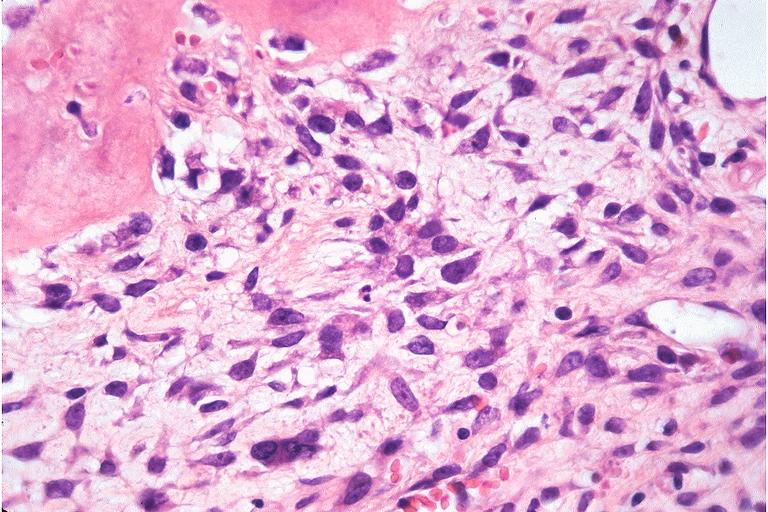s papillary intraductal adenocarcinoma present?
Answer the question using a single word or phrase. No 